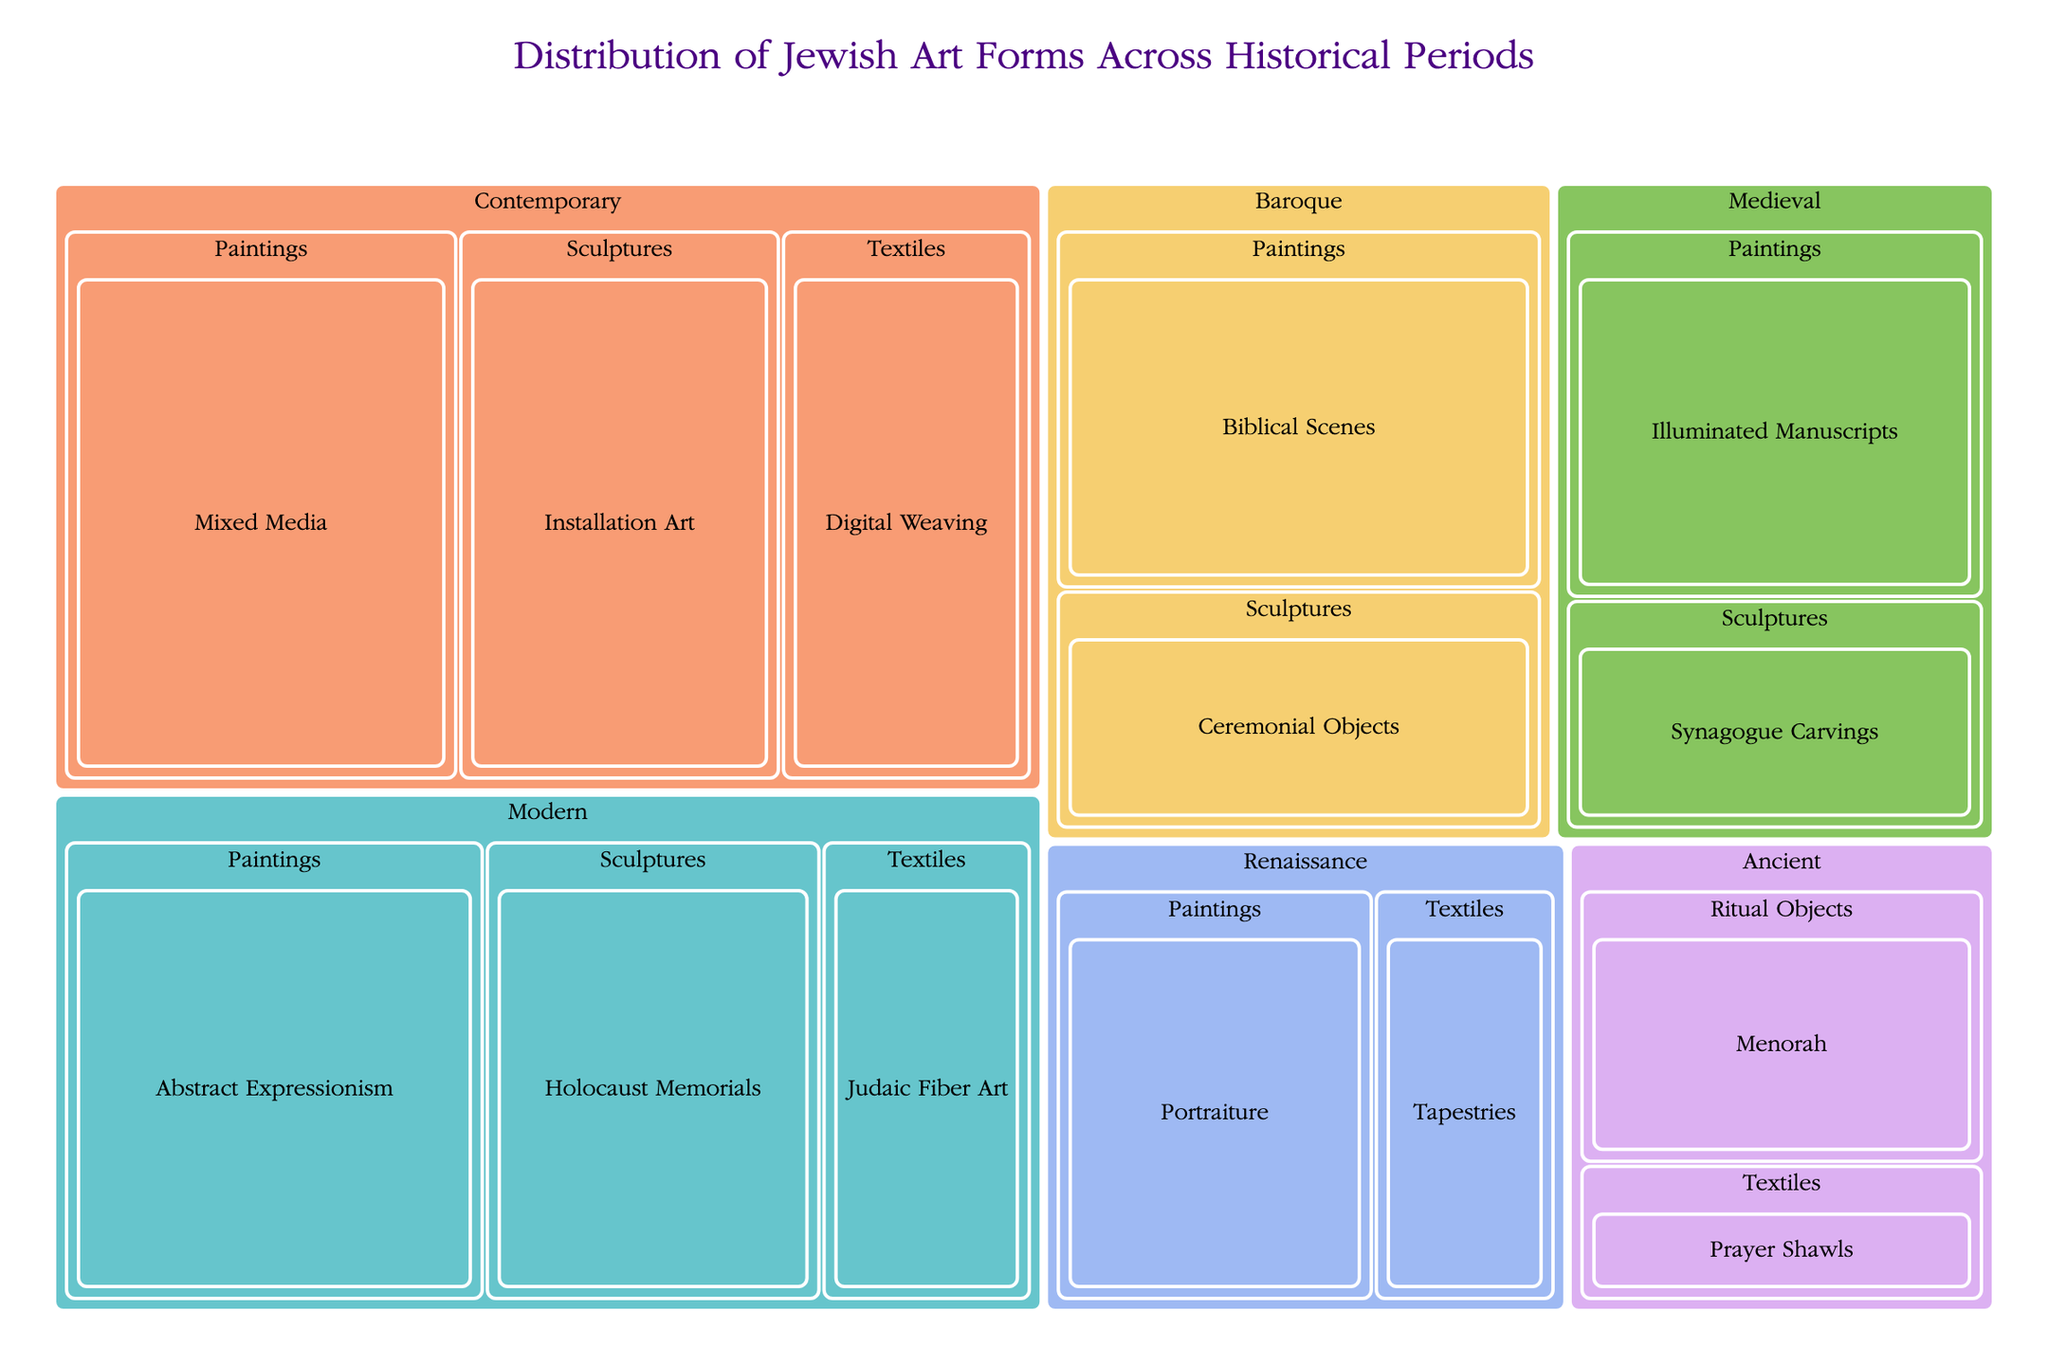What is the title of the figure? The title is displayed prominently at the top of the figure. It provides a clear indication of what the visual represents.
Answer: Distribution of Jewish Art Forms Across Historical Periods Which period has the highest combined value for all art forms? To find this, sum up the values for each art form within each period. The period with the largest total sum is the one with the highest combined value. For example, in the Modern period, add the values of Abstract Expressionism (50), Holocaust Memorials (40), and Judaic Fiber Art (25) for a total of 115. Similarly for other periods and compare.
Answer: Contemporary What is the value of "Installation Art" in the Contemporary period? Locate the "Contemporary" period, then find the "Sculptures" art form and within that, look for "Installation Art". The value should be clearly noted.
Answer: 45 Which subcategory in the Medieval period has a higher value: 'Illuminated Manuscripts' or 'Synagogue Carvings'? Compare the values of 'Illuminated Manuscripts' under "Paintings" and 'Synagogue Carvings' under "Sculptures" within the Medieval period.
Answer: Illuminated Manuscripts How does the total value of Textiles in the Medieval period compare to the total value of Textiles in the Contemporary period? Sum the values for Textiles in the Medieval and Contemporary periods and compare them. In the Medieval period, Prayer Shawls are 15, and in the Contemporary period, Digital Weaving is 35.
Answer: Contemporary has a higher value What's the sum of 'Portraiture' and 'Tapestries' values in the Renaissance period? Locate the Renaissance period, then find the values for 'Portraiture' under "Paintings" and 'Tapestries' under "Textiles". Sum these values: 35 (Portraiture) + 20 (Tapestries).
Answer: 55 Among 'Modern' and 'Renaissance', which period has a higher value for Sculptures? Compare the value of Sculptures in the Modern period (Holocaust Memorials: 40) and the Renaissance period (Ceremonial Objects: 30).
Answer: Modern Which art form in the Baroque period has a greater value, Paintings or Sculptures? Compare the summed values for Paintings and Sculptures in the Baroque period. In Paintings: Biblical Scenes (45), in Sculptures: Ceremonial Objects (30).
Answer: Paintings What is the total value of art forms in the Ancient period? Sum all the values for different subcategories and art forms in the Ancient period, including Menorah (30) and Prayer Shawls (15).
Answer: 45 Explain how to identify the most represented art form in any given period. To identify the most represented art form, look at the total value of each art form (summing up all its subcategories) in that period. The art form with the highest combined value is the most represented. Follow this method for each desired period.
Answer: Sum and compare subcategory totals 